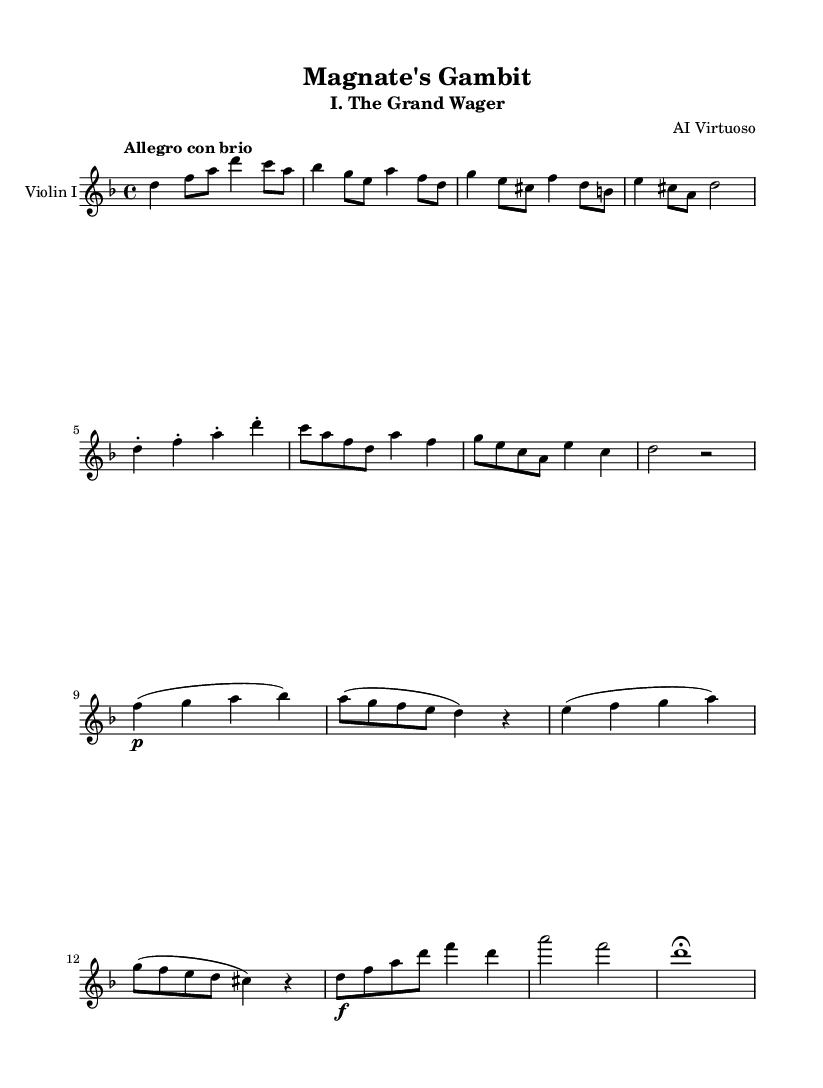What is the key signature of this music? The key signature is indicated by the sharp or flat symbols at the beginning of the staff. In the given music, there are no sharps or flats shown, so it is in D minor, which has one flat.
Answer: D minor What is the time signature of this music? The time signature is located at the beginning of the staff, indicating how many beats are in a measure. In this piece, the time signature is 4/4, which means there are four beats per measure.
Answer: 4/4 What is the tempo marking of this music? The tempo marking is found right at the start, expressing the speed of the piece. The marking "Allegro con brio" indicates a lively tempo.
Answer: Allegro con brio How many themes are presented in the piece? The piece contains two distinct themes labeled Theme A and Theme B. Each theme is recognizable by its unique melodic structure.
Answer: Two What dynamics are indicated in this music? Dynamics, which express the volume of the music, are shown using symbols and terms above or below the notes. The dynamic marking includes "p" (piano) and "f" (forte), which indicate soft and loud playing, respectively.
Answer: Piano and forte In what form is the piece structured? The structure is evident through the thematic development and reappearance within the score. This piece is structured in a symphonic form that typically includes contrasting themes and a returning coda.
Answer: Symphony What kind of articulation is present in Theme A? Articulations in music indicate how notes should be played (e.g., staccato, legato). In Theme A, the note slurs indicate that the notes should be played in a smooth, connected manner, which is a common stylistic choice in classical music.
Answer: Legato 